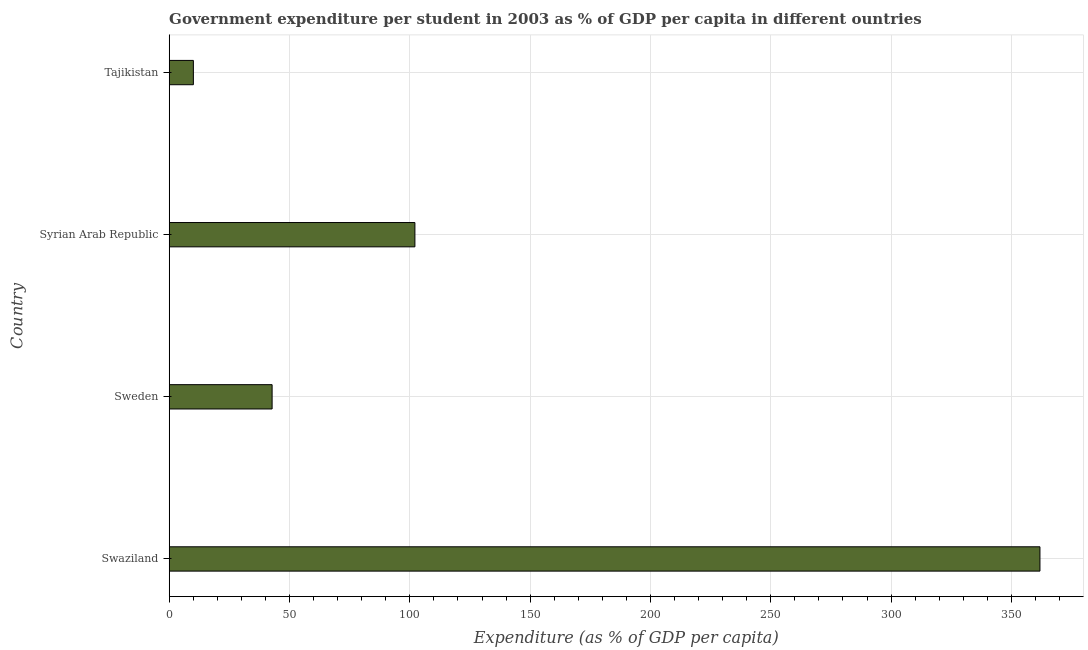Does the graph contain any zero values?
Your response must be concise. No. What is the title of the graph?
Provide a short and direct response. Government expenditure per student in 2003 as % of GDP per capita in different ountries. What is the label or title of the X-axis?
Make the answer very short. Expenditure (as % of GDP per capita). What is the label or title of the Y-axis?
Give a very brief answer. Country. What is the government expenditure per student in Tajikistan?
Offer a terse response. 10.04. Across all countries, what is the maximum government expenditure per student?
Provide a short and direct response. 361.88. Across all countries, what is the minimum government expenditure per student?
Give a very brief answer. 10.04. In which country was the government expenditure per student maximum?
Your response must be concise. Swaziland. In which country was the government expenditure per student minimum?
Your answer should be very brief. Tajikistan. What is the sum of the government expenditure per student?
Offer a terse response. 516.8. What is the difference between the government expenditure per student in Swaziland and Syrian Arab Republic?
Offer a very short reply. 259.76. What is the average government expenditure per student per country?
Provide a short and direct response. 129.2. What is the median government expenditure per student?
Keep it short and to the point. 72.44. In how many countries, is the government expenditure per student greater than 10 %?
Keep it short and to the point. 4. What is the ratio of the government expenditure per student in Syrian Arab Republic to that in Tajikistan?
Keep it short and to the point. 10.17. What is the difference between the highest and the second highest government expenditure per student?
Your answer should be compact. 259.76. Is the sum of the government expenditure per student in Sweden and Tajikistan greater than the maximum government expenditure per student across all countries?
Ensure brevity in your answer.  No. What is the difference between the highest and the lowest government expenditure per student?
Offer a terse response. 351.83. How many bars are there?
Give a very brief answer. 4. Are all the bars in the graph horizontal?
Provide a succinct answer. Yes. How many countries are there in the graph?
Make the answer very short. 4. Are the values on the major ticks of X-axis written in scientific E-notation?
Provide a short and direct response. No. What is the Expenditure (as % of GDP per capita) in Swaziland?
Provide a short and direct response. 361.88. What is the Expenditure (as % of GDP per capita) of Sweden?
Your answer should be very brief. 42.77. What is the Expenditure (as % of GDP per capita) of Syrian Arab Republic?
Ensure brevity in your answer.  102.11. What is the Expenditure (as % of GDP per capita) of Tajikistan?
Give a very brief answer. 10.04. What is the difference between the Expenditure (as % of GDP per capita) in Swaziland and Sweden?
Give a very brief answer. 319.11. What is the difference between the Expenditure (as % of GDP per capita) in Swaziland and Syrian Arab Republic?
Provide a succinct answer. 259.76. What is the difference between the Expenditure (as % of GDP per capita) in Swaziland and Tajikistan?
Offer a terse response. 351.83. What is the difference between the Expenditure (as % of GDP per capita) in Sweden and Syrian Arab Republic?
Give a very brief answer. -59.35. What is the difference between the Expenditure (as % of GDP per capita) in Sweden and Tajikistan?
Offer a terse response. 32.73. What is the difference between the Expenditure (as % of GDP per capita) in Syrian Arab Republic and Tajikistan?
Offer a terse response. 92.07. What is the ratio of the Expenditure (as % of GDP per capita) in Swaziland to that in Sweden?
Offer a terse response. 8.46. What is the ratio of the Expenditure (as % of GDP per capita) in Swaziland to that in Syrian Arab Republic?
Your answer should be compact. 3.54. What is the ratio of the Expenditure (as % of GDP per capita) in Swaziland to that in Tajikistan?
Keep it short and to the point. 36.03. What is the ratio of the Expenditure (as % of GDP per capita) in Sweden to that in Syrian Arab Republic?
Make the answer very short. 0.42. What is the ratio of the Expenditure (as % of GDP per capita) in Sweden to that in Tajikistan?
Keep it short and to the point. 4.26. What is the ratio of the Expenditure (as % of GDP per capita) in Syrian Arab Republic to that in Tajikistan?
Offer a terse response. 10.17. 